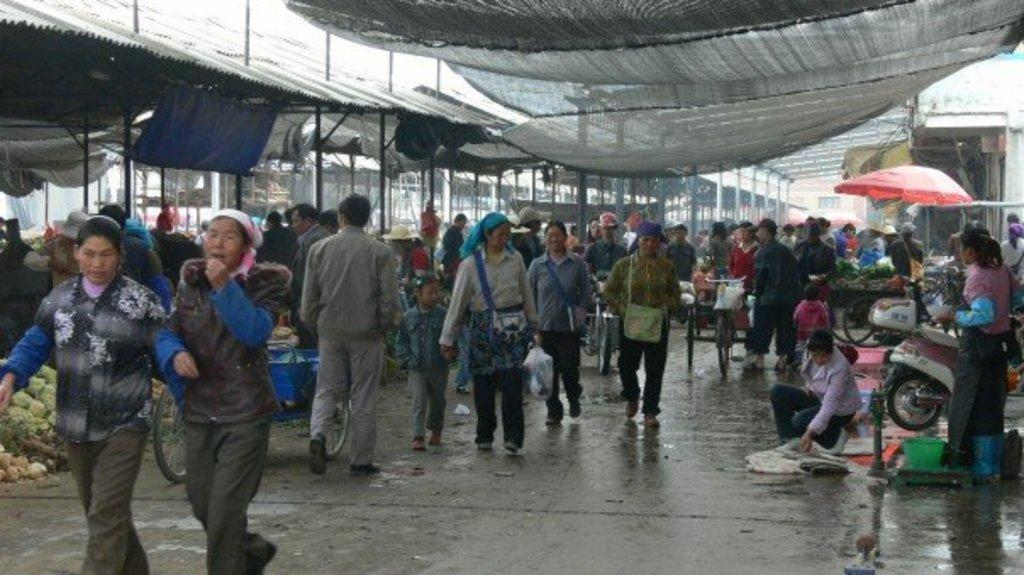How many people are in the group visible in the image? There is a group of persons in the image, but the exact number cannot be determined from the provided facts. What are the persons in the image doing? The persons in the image are walking under nets. What types of food can be seen in the image? There are vegetables and fruits in the image. What else can be seen in the image besides the group of persons and food items? There are vehicles and houses in the background of the image. What type of grape is being used as a sweater in the image? There is no grape being used as a sweater in the image; grapes are a type of fruit, and the image does not depict any clothing items. 